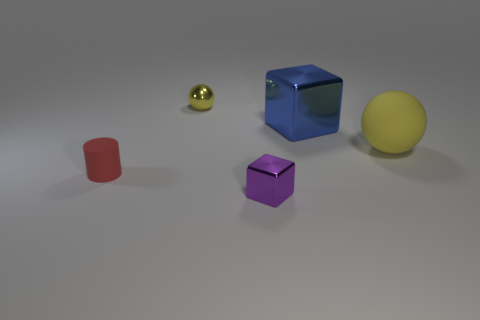Is there anything else that has the same size as the purple thing?
Your response must be concise. Yes. Is the big metallic cube the same color as the tiny rubber object?
Keep it short and to the point. No. Is the number of small yellow spheres greater than the number of big green matte cubes?
Ensure brevity in your answer.  Yes. What number of other objects are the same color as the large ball?
Your answer should be very brief. 1. What number of small metal spheres are in front of the small metallic object in front of the small yellow sphere?
Your response must be concise. 0. Are there any tiny red matte cylinders in front of the big sphere?
Offer a very short reply. Yes. What shape is the tiny shiny object that is behind the yellow ball right of the blue block?
Your answer should be very brief. Sphere. Is the number of tiny purple metal objects that are on the right side of the yellow rubber sphere less than the number of small red matte cylinders behind the big blue thing?
Provide a succinct answer. No. What is the color of the other thing that is the same shape as the blue metallic thing?
Provide a succinct answer. Purple. What number of metal objects are both behind the small red rubber thing and to the right of the shiny ball?
Keep it short and to the point. 1. 